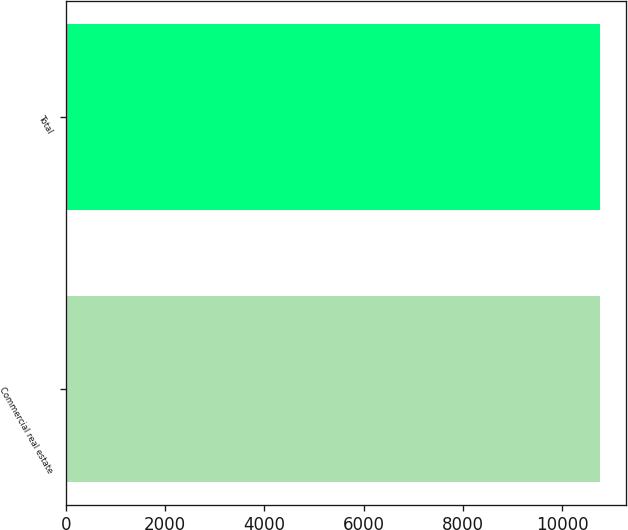Convert chart. <chart><loc_0><loc_0><loc_500><loc_500><bar_chart><fcel>Commercial real estate<fcel>Total<nl><fcel>10750<fcel>10750.1<nl></chart> 